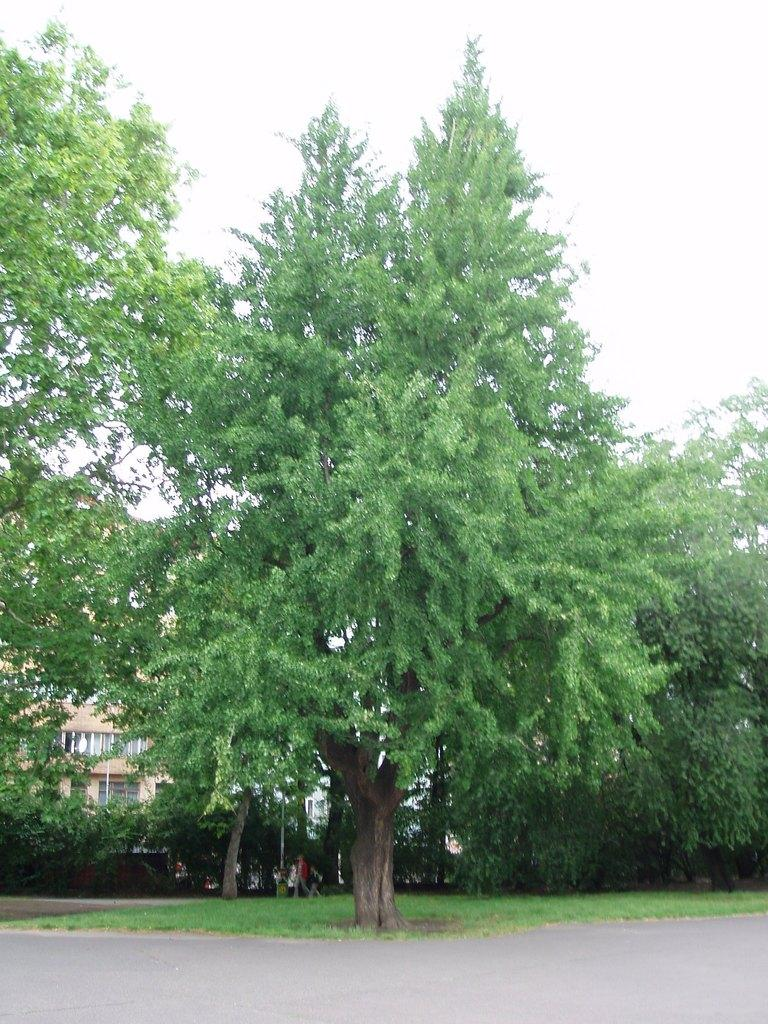What type of vegetation is present in the image? There are trees in the image. What is the color of the trees? The trees are green in color. What can be seen in the background of the image? There is a building in the background of the image. What are the colors of the building? The building is in cream and white colors. What is visible above the trees and building in the image? The sky is visible in the image. What is the color of the sky? The sky is white in color. Where is the spade located in the image? There is no spade present in the image. What type of property is being sold in the image? There is no indication of any property being sold in the image. 